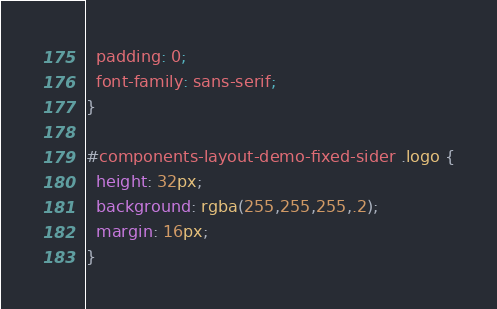Convert code to text. <code><loc_0><loc_0><loc_500><loc_500><_CSS_>  padding: 0;
  font-family: sans-serif;
}

#components-layout-demo-fixed-sider .logo {
  height: 32px;
  background: rgba(255,255,255,.2);
  margin: 16px;
}</code> 